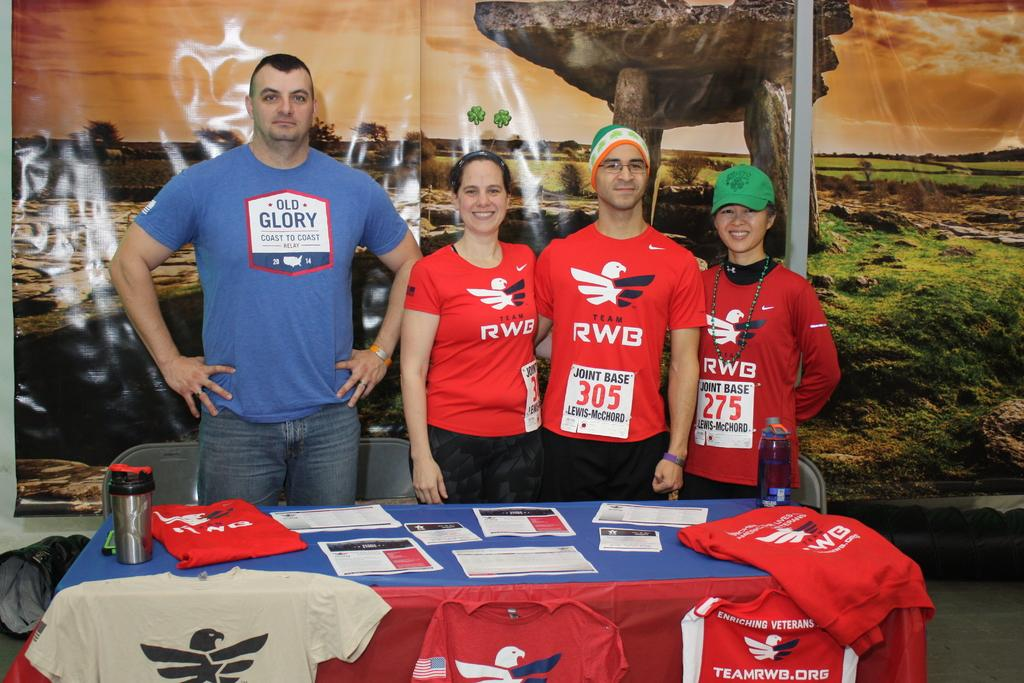Provide a one-sentence caption for the provided image. people standing behind a display table in shirts reading RWB. 